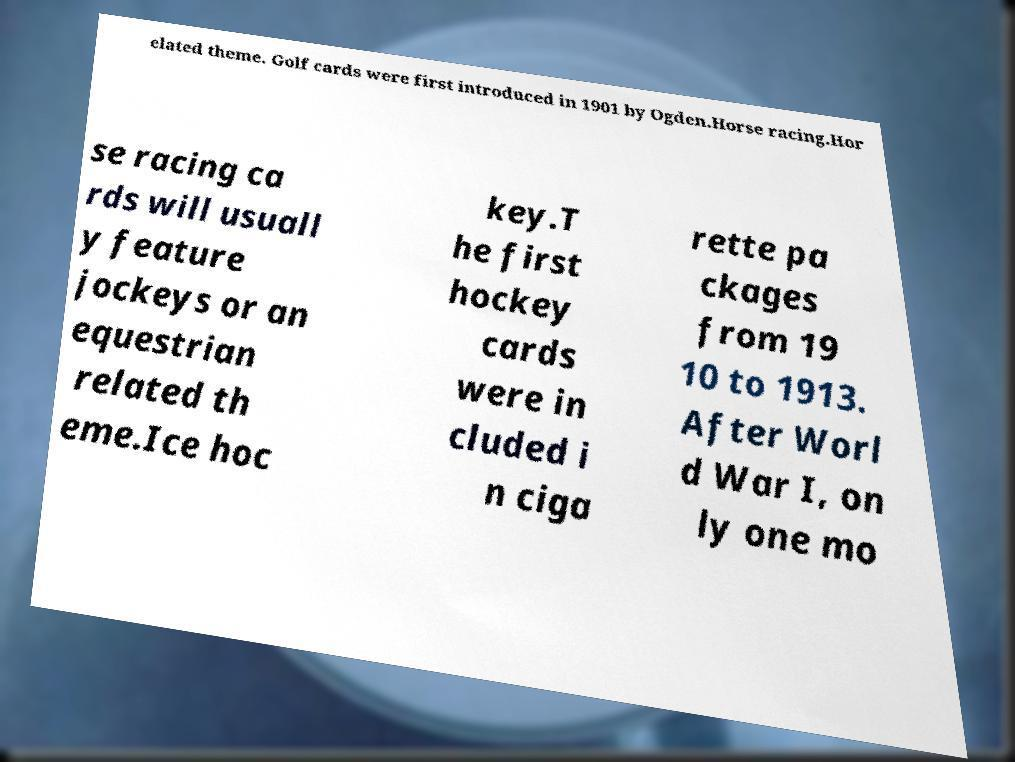For documentation purposes, I need the text within this image transcribed. Could you provide that? elated theme. Golf cards were first introduced in 1901 by Ogden.Horse racing.Hor se racing ca rds will usuall y feature jockeys or an equestrian related th eme.Ice hoc key.T he first hockey cards were in cluded i n ciga rette pa ckages from 19 10 to 1913. After Worl d War I, on ly one mo 